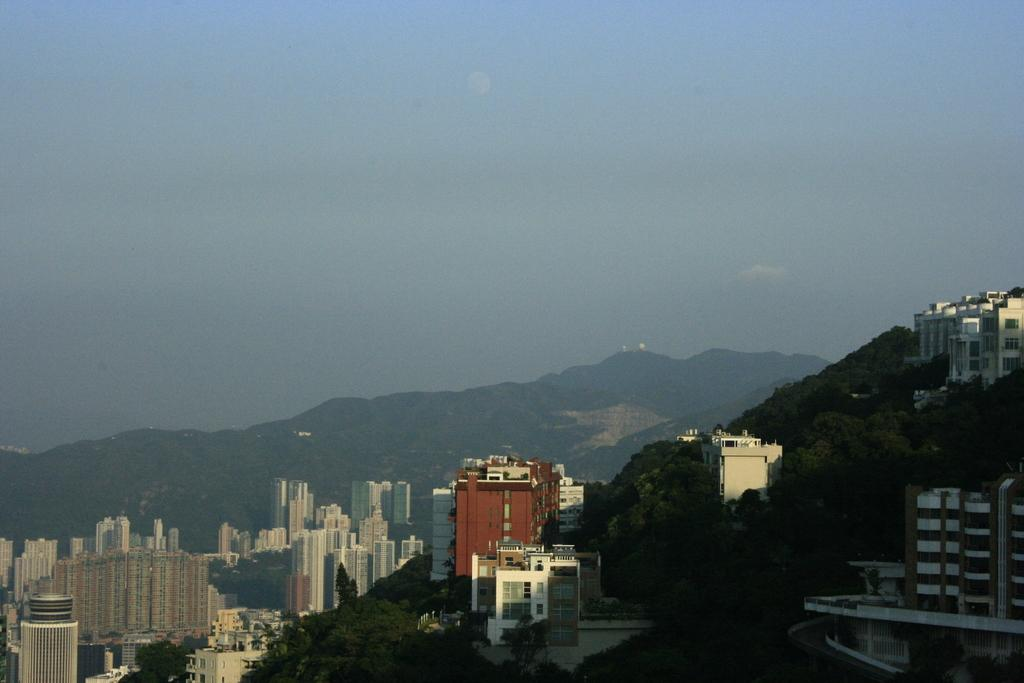What type of structures are located at the bottom of the image? There are buildings at the bottom of the image. What can be seen in the middle of the image? There are trees in the middle of the image. What is visible at the top of the image? The sky is visible at the top of the image. Can you tell me how many mittens are hanging from the trees in the image? There are no mittens present in the image; it features buildings, trees, and the sky. What type of wine is being served in the image? There is no wine present in the image. 